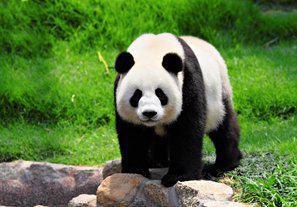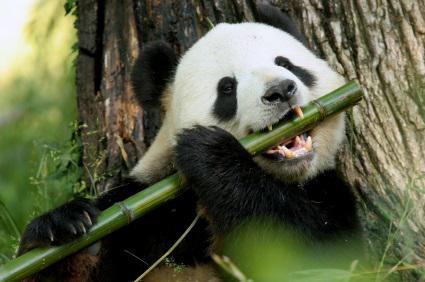The first image is the image on the left, the second image is the image on the right. For the images displayed, is the sentence "The panda in one of the images is standing on all fours in the grass." factually correct? Answer yes or no. Yes. The first image is the image on the left, the second image is the image on the right. Given the left and right images, does the statement "The panda in the left photo is holding a piece of wood in its paw." hold true? Answer yes or no. No. 